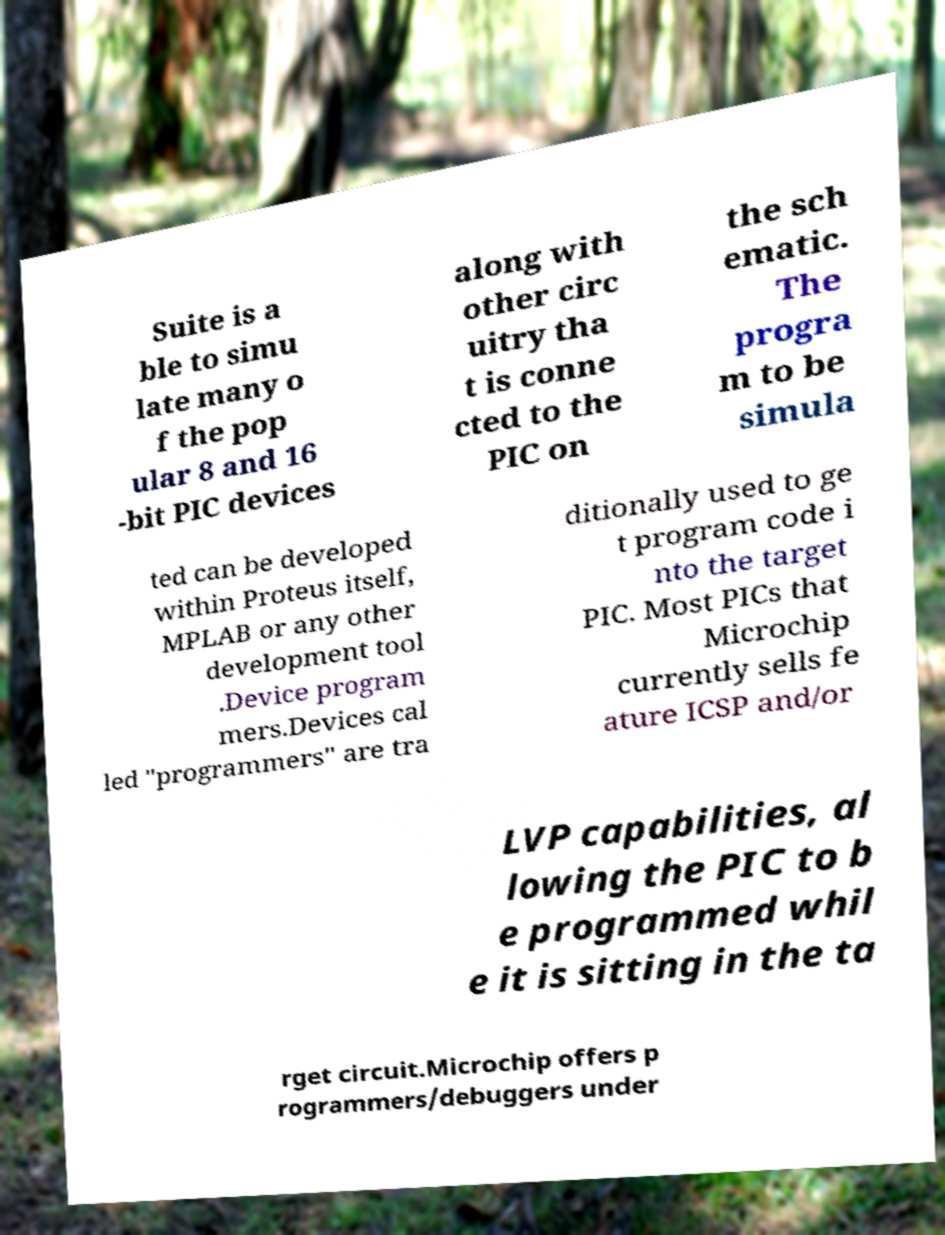Could you assist in decoding the text presented in this image and type it out clearly? Suite is a ble to simu late many o f the pop ular 8 and 16 -bit PIC devices along with other circ uitry tha t is conne cted to the PIC on the sch ematic. The progra m to be simula ted can be developed within Proteus itself, MPLAB or any other development tool .Device program mers.Devices cal led "programmers" are tra ditionally used to ge t program code i nto the target PIC. Most PICs that Microchip currently sells fe ature ICSP and/or LVP capabilities, al lowing the PIC to b e programmed whil e it is sitting in the ta rget circuit.Microchip offers p rogrammers/debuggers under 